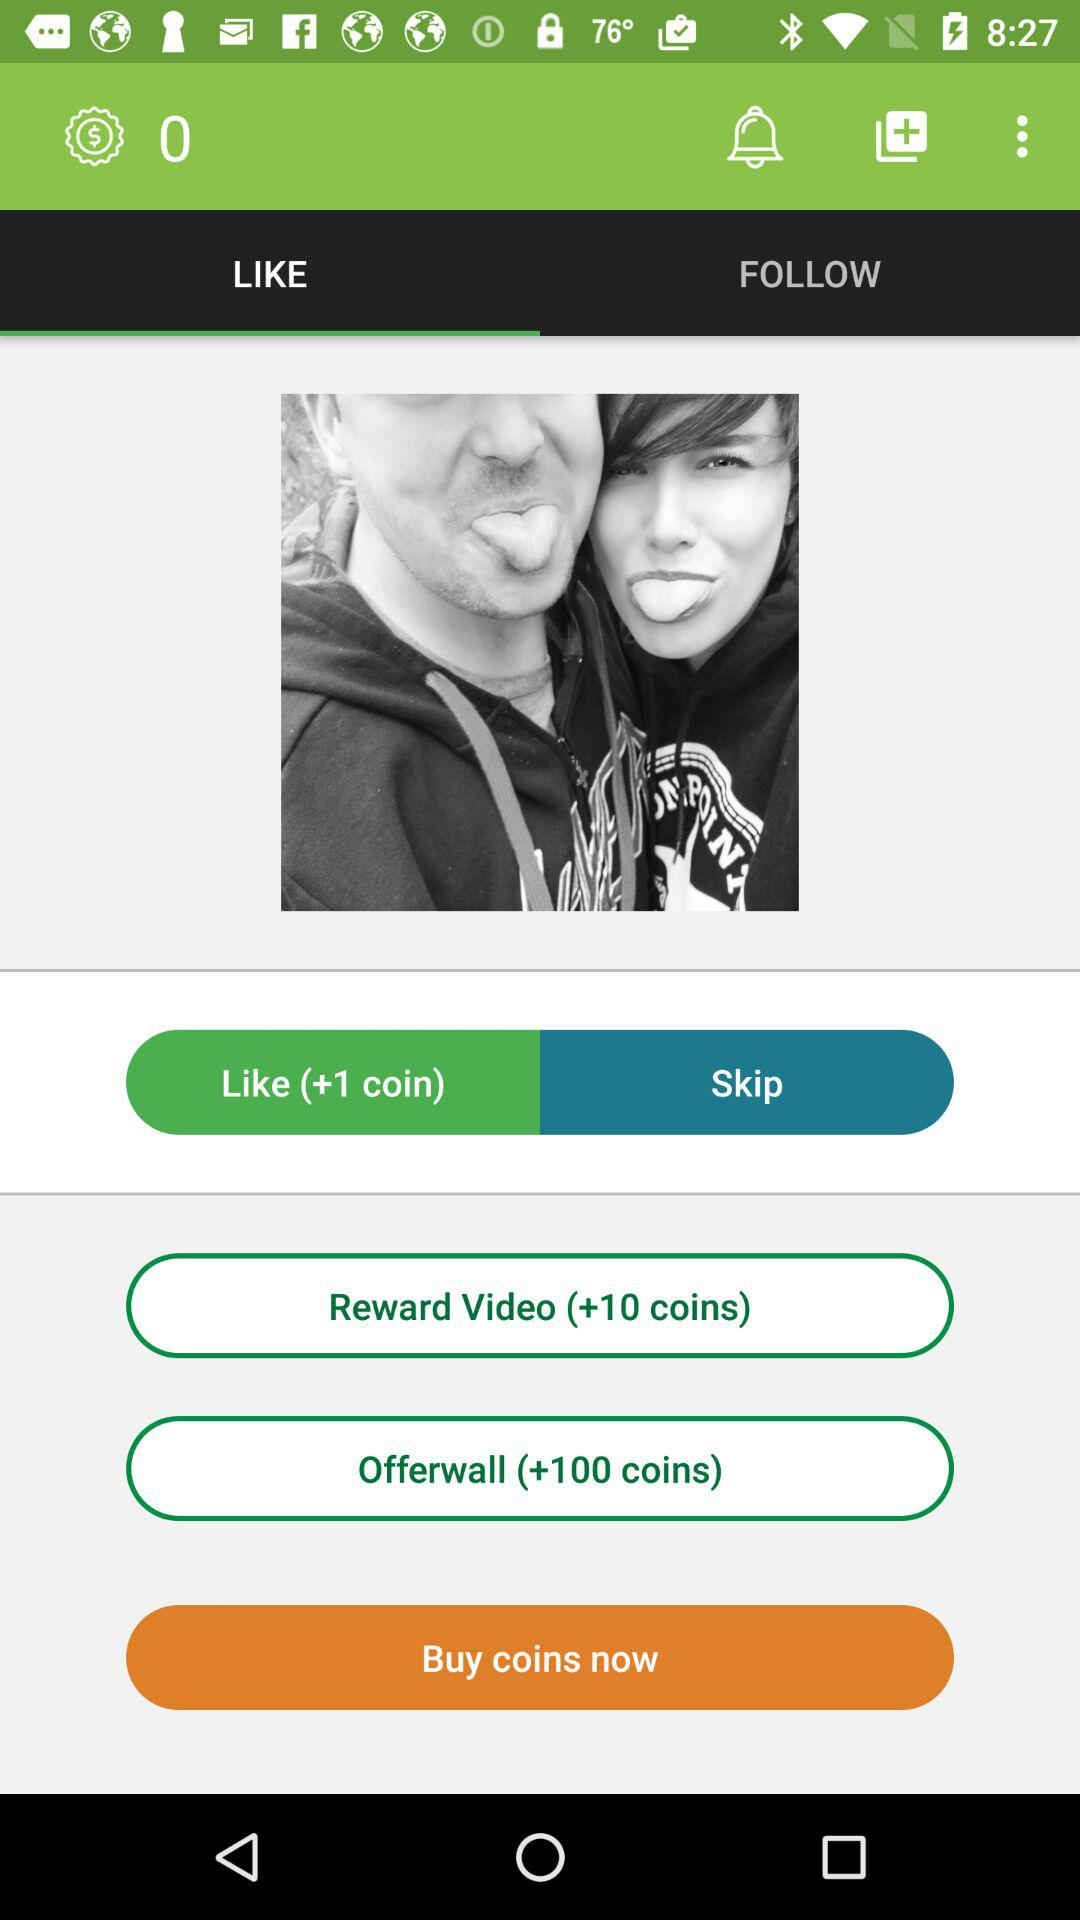How many coins are counted on the Offerwall? The counted coins are +100. 